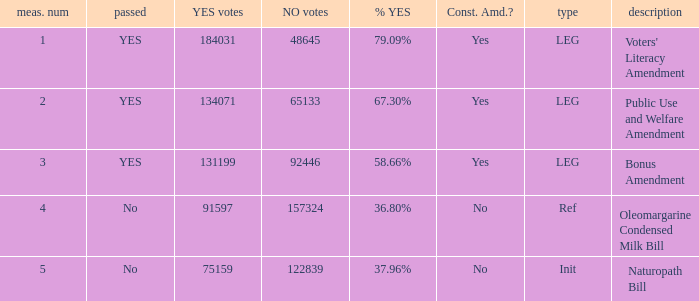What is the dimension number for the init type? 5.0. 